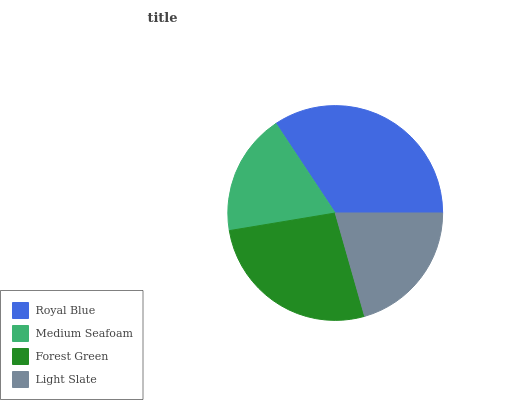Is Medium Seafoam the minimum?
Answer yes or no. Yes. Is Royal Blue the maximum?
Answer yes or no. Yes. Is Forest Green the minimum?
Answer yes or no. No. Is Forest Green the maximum?
Answer yes or no. No. Is Forest Green greater than Medium Seafoam?
Answer yes or no. Yes. Is Medium Seafoam less than Forest Green?
Answer yes or no. Yes. Is Medium Seafoam greater than Forest Green?
Answer yes or no. No. Is Forest Green less than Medium Seafoam?
Answer yes or no. No. Is Forest Green the high median?
Answer yes or no. Yes. Is Light Slate the low median?
Answer yes or no. Yes. Is Light Slate the high median?
Answer yes or no. No. Is Royal Blue the low median?
Answer yes or no. No. 